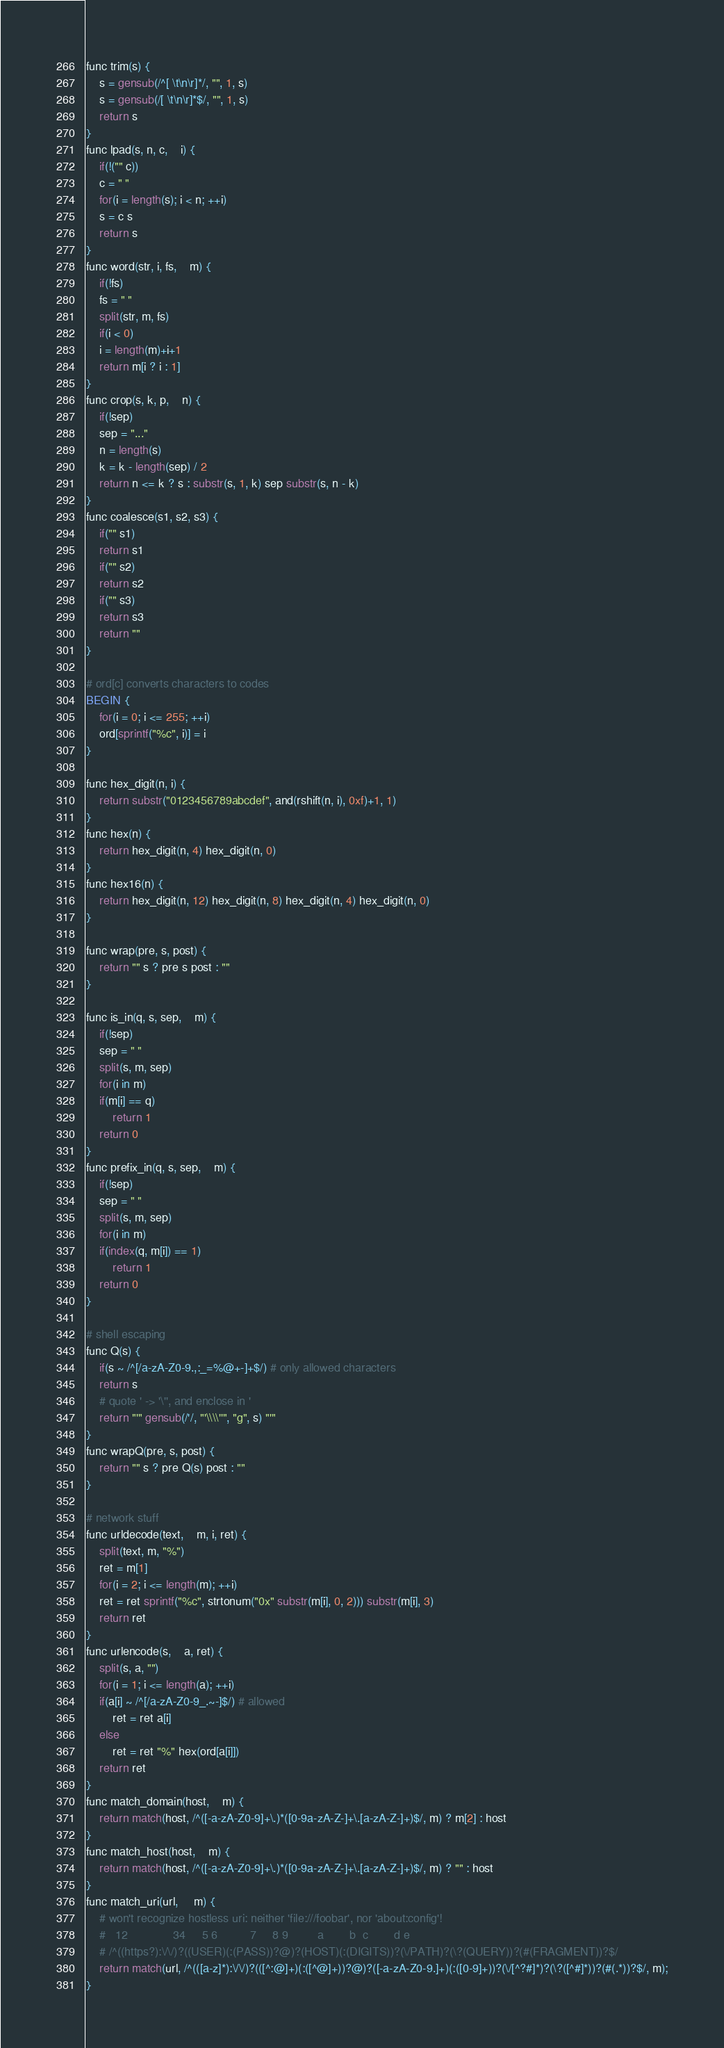Convert code to text. <code><loc_0><loc_0><loc_500><loc_500><_Awk_>
func trim(s) {
    s = gensub(/^[ \t\n\r]*/, "", 1, s)
    s = gensub(/[ \t\n\r]*$/, "", 1, s)
    return s
}
func lpad(s, n, c,    i) {
    if(!("" c))
	c = " "
    for(i = length(s); i < n; ++i)
	s = c s
    return s
}
func word(str, i, fs,    m) {
    if(!fs)
	fs = " "
    split(str, m, fs)
    if(i < 0)
	i = length(m)+i+1
    return m[i ? i : 1]
}
func crop(s, k, p,    n) {
    if(!sep)
	sep = "..."
    n = length(s)
    k = k - length(sep) / 2
    return n <= k ? s : substr(s, 1, k) sep substr(s, n - k)
}
func coalesce(s1, s2, s3) {
    if("" s1)
	return s1
    if("" s2)
	return s2
    if("" s3)
	return s3
    return ""
}

# ord[c] converts characters to codes
BEGIN {
    for(i = 0; i <= 255; ++i)
	ord[sprintf("%c", i)] = i
}

func hex_digit(n, i) {
    return substr("0123456789abcdef", and(rshift(n, i), 0xf)+1, 1)
}
func hex(n) {
    return hex_digit(n, 4) hex_digit(n, 0)
}
func hex16(n) {
    return hex_digit(n, 12) hex_digit(n, 8) hex_digit(n, 4) hex_digit(n, 0)
}

func wrap(pre, s, post) {
    return "" s ? pre s post : ""
}

func is_in(q, s, sep,    m) {
    if(!sep)
	sep = " "
    split(s, m, sep)
    for(i in m)
	if(m[i] == q)
	    return 1
    return 0
}
func prefix_in(q, s, sep,    m) {
    if(!sep)
	sep = " "
    split(s, m, sep)
    for(i in m)
	if(index(q, m[i]) == 1)
	    return 1
    return 0
}

# shell escaping
func Q(s) {
    if(s ~ /^[/a-zA-Z0-9.,:_=%@+-]+$/) # only allowed characters
	return s
    # quote ' -> '\'', and enclose in '
    return "'" gensub(/'/, "'\\\\''", "g", s) "'"
}
func wrapQ(pre, s, post) {
    return "" s ? pre Q(s) post : ""
}

# network stuff
func urldecode(text,    m, i, ret) {
    split(text, m, "%")
    ret = m[1]
    for(i = 2; i <= length(m); ++i)
	ret = ret sprintf("%c", strtonum("0x" substr(m[i], 0, 2))) substr(m[i], 3)
    return ret
}
func urlencode(s,    a, ret) {
    split(s, a, "")
    for(i = 1; i <= length(a); ++i)
	if(a[i] ~ /^[/a-zA-Z0-9_.~-]$/) # allowed
	    ret = ret a[i]
	else
	    ret = ret "%" hex(ord[a[i]])
    return ret
}
func match_domain(host,    m) {
    return match(host, /^([-a-zA-Z0-9]+\.)*([0-9a-zA-Z-]+\.[a-zA-Z-]+)$/, m) ? m[2] : host
}
func match_host(host,    m) {
    return match(host, /^([-a-zA-Z0-9]+\.)*([0-9a-zA-Z-]+\.[a-zA-Z-]+)$/, m) ? "" : host
}
func match_uri(url,     m) {
    # won't recognize hostless uri: neither 'file:///foobar', nor 'about:config'!
    #   12              34     5 6          7     8 9         a        b  c        d e
    # /^((https?):\/\/)?((USER)(:(PASS))?@)?(HOST)(:(DIGITS))?(\/PATH)?(\?(QUERY))?(#(FRAGMENT))?$/
    return match(url, /^(([a-z]*):\/\/)?(([^:@]+)(:([^@]+))?@)?([-a-zA-Z0-9.]+)(:([0-9]+))?(\/[^?#]*)?(\?([^#]*))?(#(.*))?$/, m);
}
</code> 